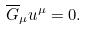<formula> <loc_0><loc_0><loc_500><loc_500>\overline { G } _ { \mu } u ^ { \mu } = 0 .</formula> 